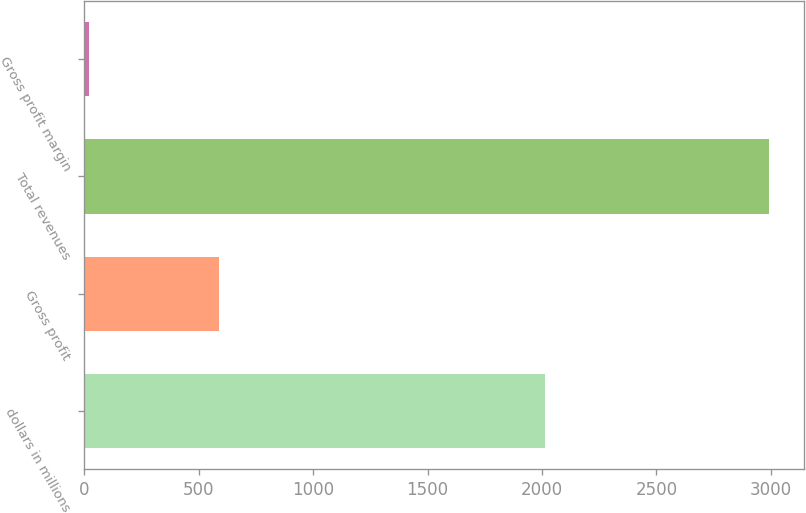Convert chart. <chart><loc_0><loc_0><loc_500><loc_500><bar_chart><fcel>dollars in millions<fcel>Gross profit<fcel>Total revenues<fcel>Gross profit margin<nl><fcel>2014<fcel>587.6<fcel>2994.2<fcel>19.6<nl></chart> 